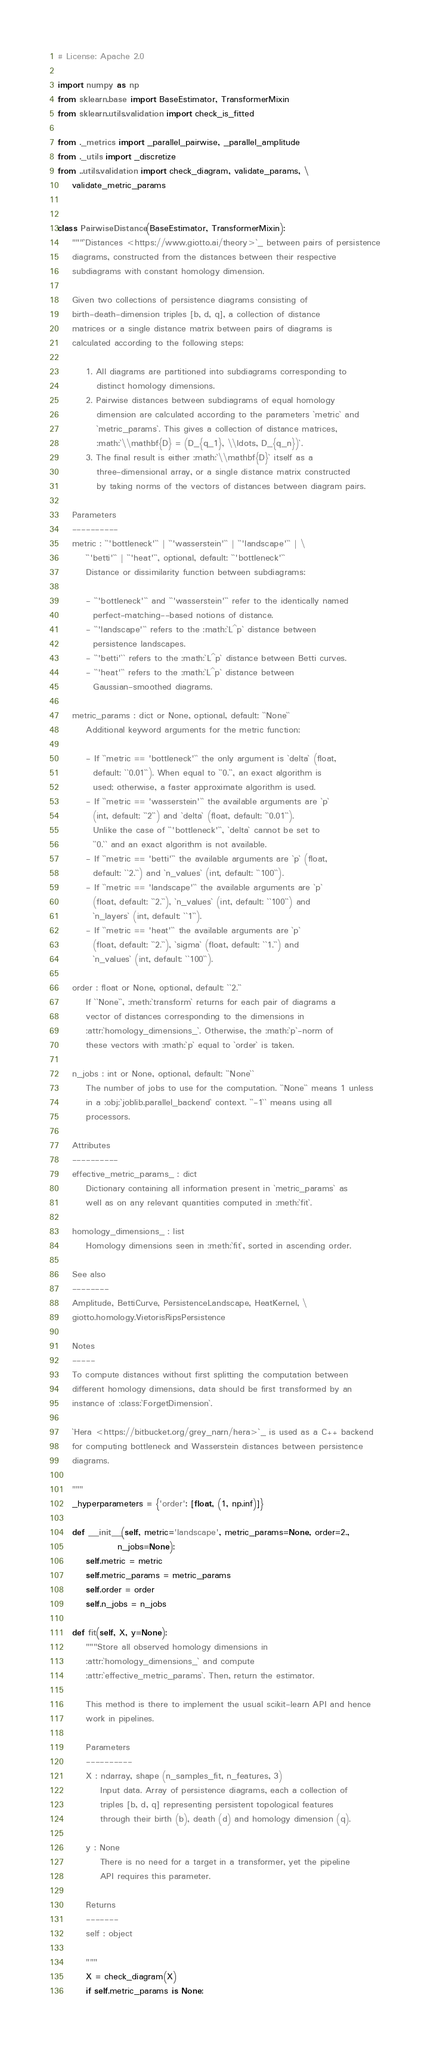Convert code to text. <code><loc_0><loc_0><loc_500><loc_500><_Python_># License: Apache 2.0

import numpy as np
from sklearn.base import BaseEstimator, TransformerMixin
from sklearn.utils.validation import check_is_fitted

from ._metrics import _parallel_pairwise, _parallel_amplitude
from ._utils import _discretize
from ..utils.validation import check_diagram, validate_params, \
    validate_metric_params


class PairwiseDistance(BaseEstimator, TransformerMixin):
    """`Distances <https://www.giotto.ai/theory>`_ between pairs of persistence
    diagrams, constructed from the distances between their respective
    subdiagrams with constant homology dimension.

    Given two collections of persistence diagrams consisting of
    birth-death-dimension triples [b, d, q], a collection of distance
    matrices or a single distance matrix between pairs of diagrams is
    calculated according to the following steps:

        1. All diagrams are partitioned into subdiagrams corresponding to
           distinct homology dimensions.
        2. Pairwise distances between subdiagrams of equal homology
           dimension are calculated according to the parameters `metric` and
           `metric_params`. This gives a collection of distance matrices,
           :math:`\\mathbf{D} = (D_{q_1}, \\ldots, D_{q_n})`.
        3. The final result is either :math:`\\mathbf{D}` itself as a
           three-dimensional array, or a single distance matrix constructed
           by taking norms of the vectors of distances between diagram pairs.

    Parameters
    ----------
    metric : ``'bottleneck'`` | ``'wasserstein'`` | ``'landscape'`` | \
        ``'betti'`` | ``'heat'``, optional, default: ``'bottleneck'``
        Distance or dissimilarity function between subdiagrams:

        - ``'bottleneck'`` and ``'wasserstein'`` refer to the identically named
          perfect-matching--based notions of distance.
        - ``'landscape'`` refers to the :math:`L^p` distance between
          persistence landscapes.
        - ``'betti'`` refers to the :math:`L^p` distance between Betti curves.
        - ``'heat'`` refers to the :math:`L^p` distance between
          Gaussian-smoothed diagrams.

    metric_params : dict or None, optional, default: ``None``
        Additional keyword arguments for the metric function:

        - If ``metric == 'bottleneck'`` the only argument is `delta` (float,
          default: ``0.01``). When equal to ``0.``, an exact algorithm is
          used; otherwise, a faster approximate algorithm is used.
        - If ``metric == 'wasserstein'`` the available arguments are `p`
          (int, default: ``2``) and `delta` (float, default: ``0.01``).
          Unlike the case of ``'bottleneck'``, `delta` cannot be set to
          ``0.`` and an exact algorithm is not available.
        - If ``metric == 'betti'`` the available arguments are `p` (float,
          default: ``2.``) and `n_values` (int, default: ``100``).
        - If ``metric == 'landscape'`` the available arguments are `p`
          (float, default: ``2.``), `n_values` (int, default: ``100``) and
          `n_layers` (int, default: ``1``).
        - If ``metric == 'heat'`` the available arguments are `p`
          (float, default: ``2.``), `sigma` (float, default: ``1.``) and
          `n_values` (int, default: ``100``).

    order : float or None, optional, default: ``2.``
        If ``None``, :meth:`transform` returns for each pair of diagrams a
        vector of distances corresponding to the dimensions in
        :attr:`homology_dimensions_`. Otherwise, the :math:`p`-norm of
        these vectors with :math:`p` equal to `order` is taken.

    n_jobs : int or None, optional, default: ``None``
        The number of jobs to use for the computation. ``None`` means 1 unless
        in a :obj:`joblib.parallel_backend` context. ``-1`` means using all
        processors.

    Attributes
    ----------
    effective_metric_params_ : dict
        Dictionary containing all information present in `metric_params` as
        well as on any relevant quantities computed in :meth:`fit`.

    homology_dimensions_ : list
        Homology dimensions seen in :meth:`fit`, sorted in ascending order.

    See also
    --------
    Amplitude, BettiCurve, PersistenceLandscape, HeatKernel, \
    giotto.homology.VietorisRipsPersistence

    Notes
    -----
    To compute distances without first splitting the computation between
    different homology dimensions, data should be first transformed by an
    instance of :class:`ForgetDimension`.

    `Hera <https://bitbucket.org/grey_narn/hera>`_ is used as a C++ backend
    for computing bottleneck and Wasserstein distances between persistence
    diagrams.

    """
    _hyperparameters = {'order': [float, (1, np.inf)]}

    def __init__(self, metric='landscape', metric_params=None, order=2.,
                 n_jobs=None):
        self.metric = metric
        self.metric_params = metric_params
        self.order = order
        self.n_jobs = n_jobs

    def fit(self, X, y=None):
        """Store all observed homology dimensions in
        :attr:`homology_dimensions_` and compute
        :attr:`effective_metric_params`. Then, return the estimator.

        This method is there to implement the usual scikit-learn API and hence
        work in pipelines.

        Parameters
        ----------
        X : ndarray, shape (n_samples_fit, n_features, 3)
            Input data. Array of persistence diagrams, each a collection of
            triples [b, d, q] representing persistent topological features
            through their birth (b), death (d) and homology dimension (q).

        y : None
            There is no need for a target in a transformer, yet the pipeline
            API requires this parameter.

        Returns
        -------
        self : object

        """
        X = check_diagram(X)
        if self.metric_params is None:</code> 